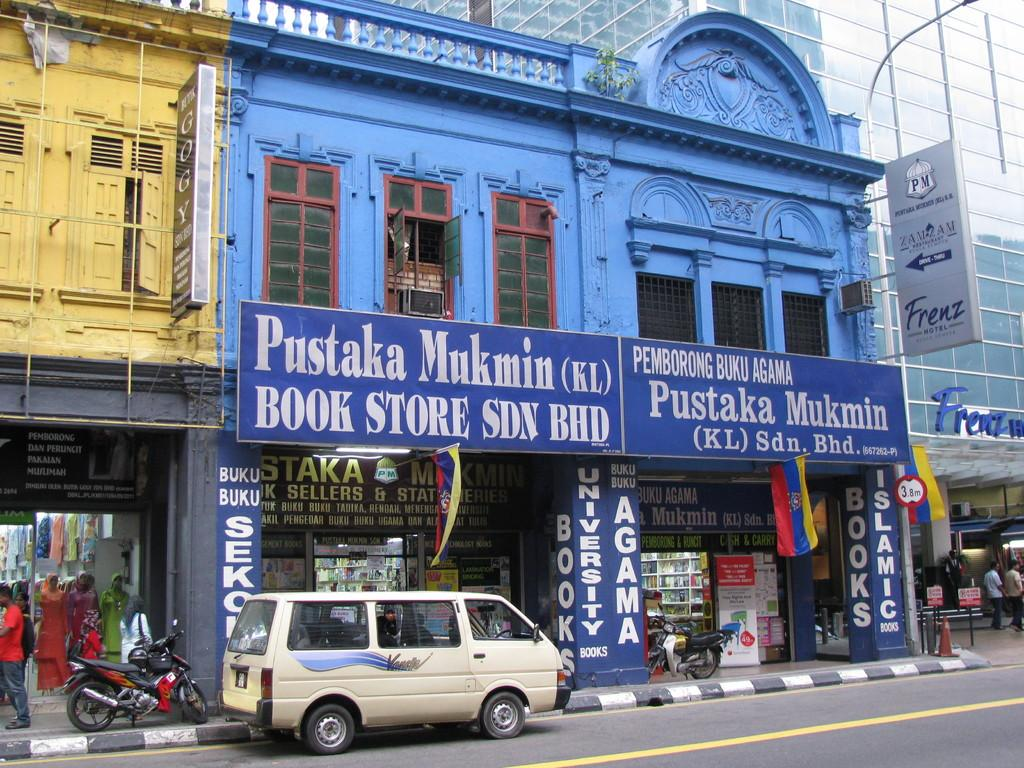<image>
Render a clear and concise summary of the photo. A big blue building, which houses a bookstore, sits on the side of the road. 